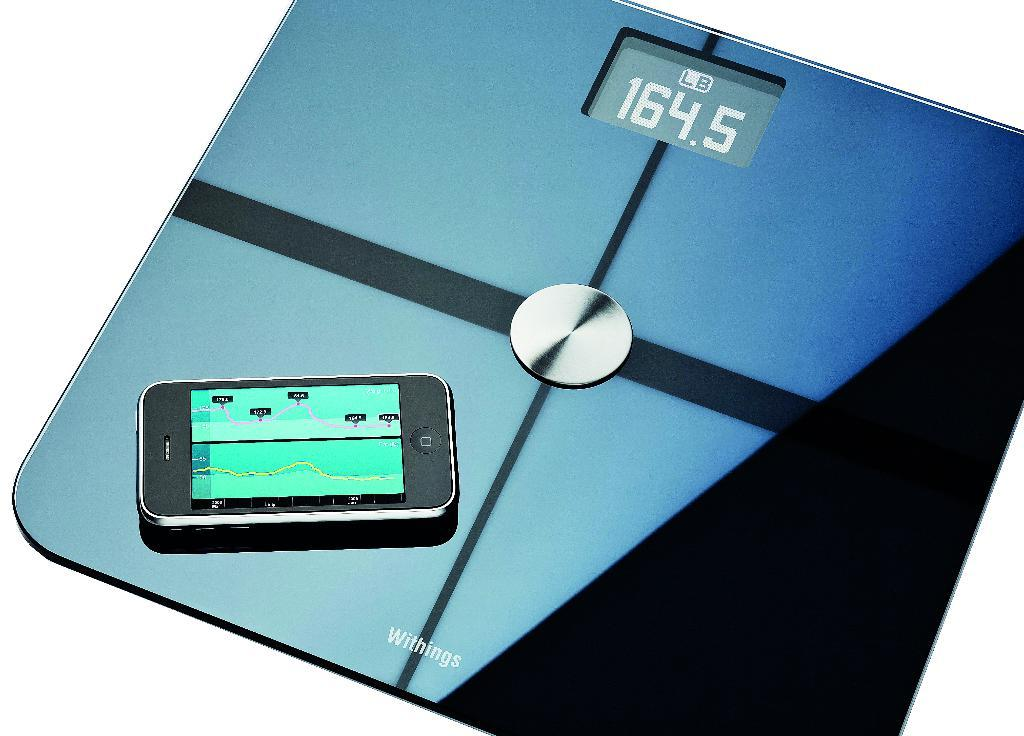<image>
Write a terse but informative summary of the picture. A digital scale with a cell phone on it and a display of 164.5 